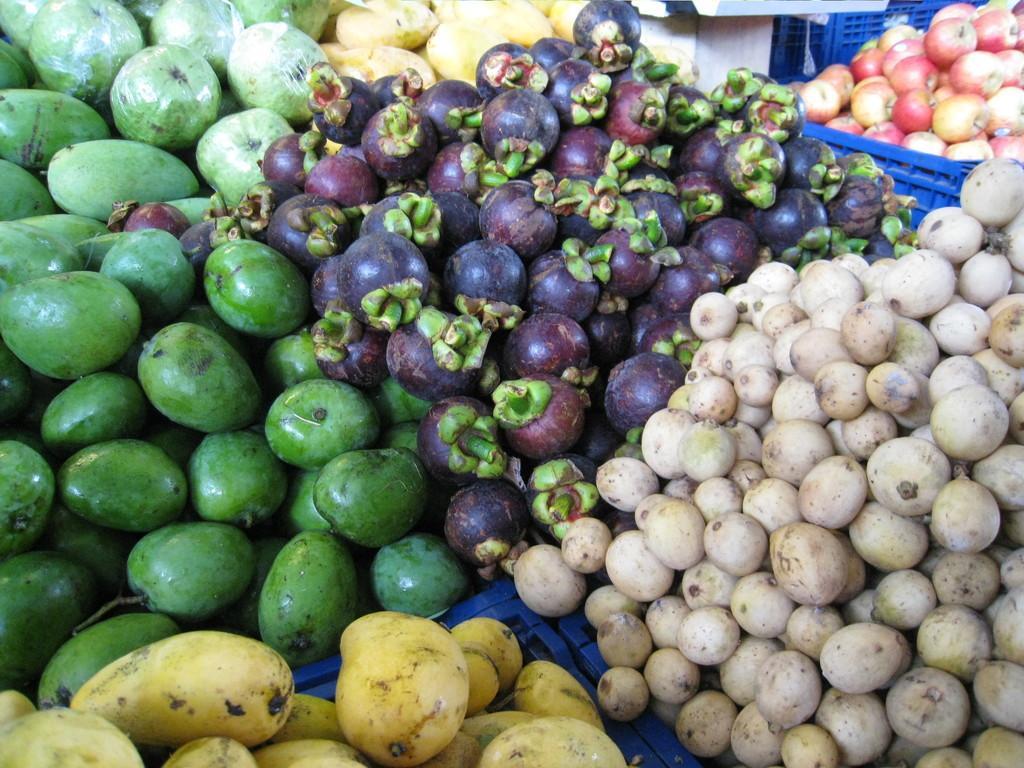In one or two sentences, can you explain what this image depicts? In this image we can see fruits placed on the containers. 